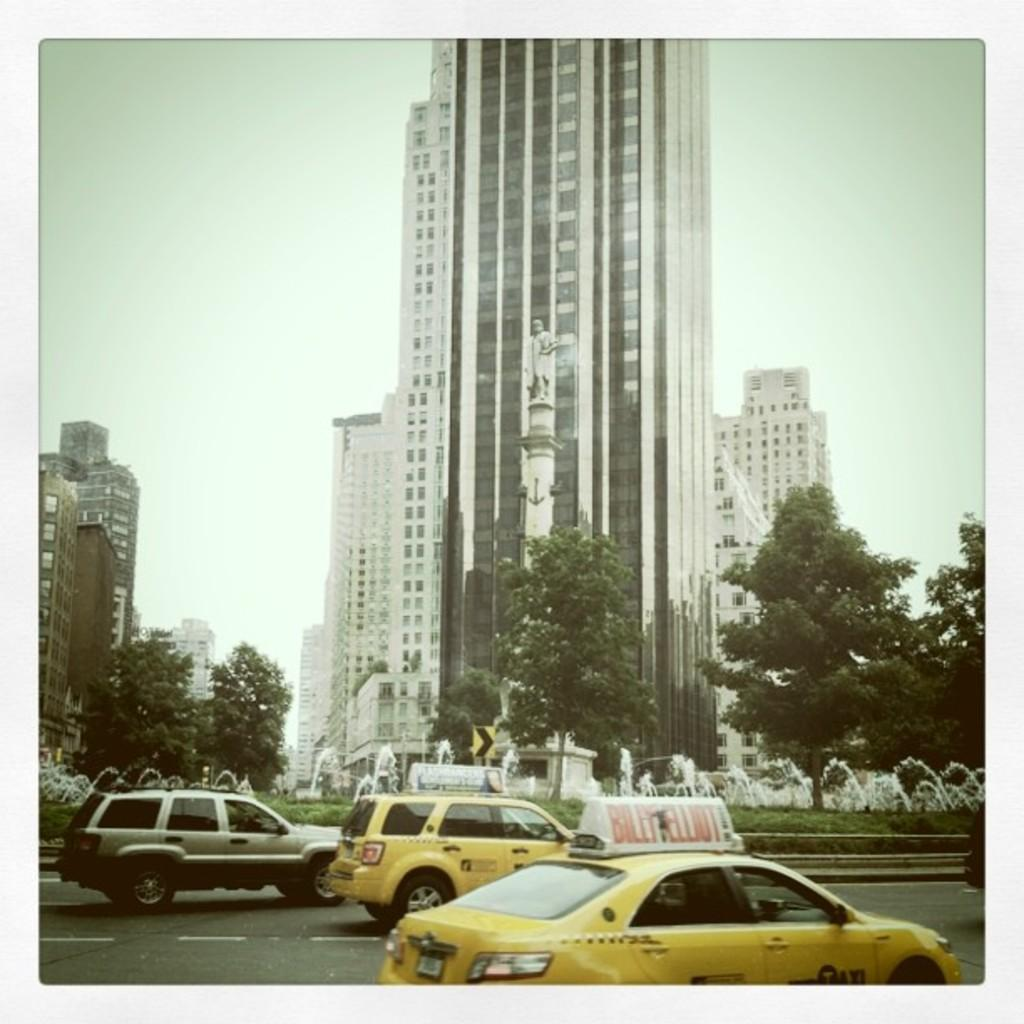Provide a one-sentence caption for the provided image. The taxis passed near the old building of the former regime. 